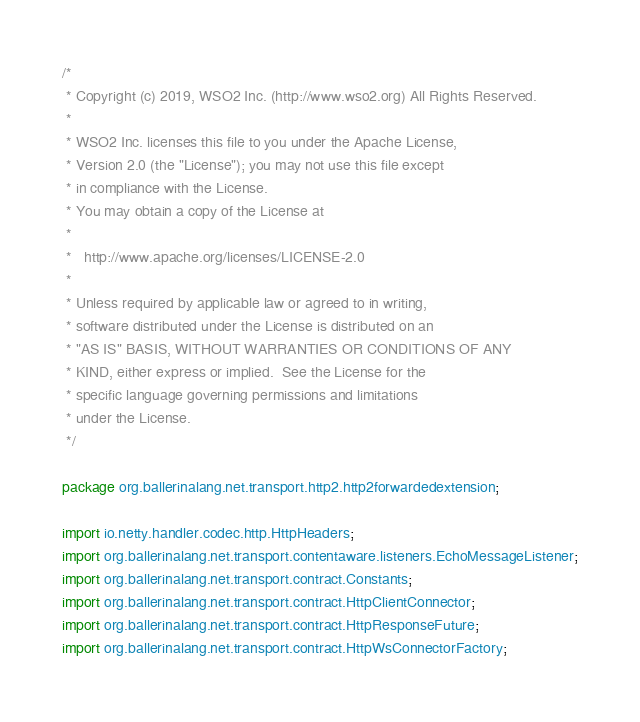<code> <loc_0><loc_0><loc_500><loc_500><_Java_>/*
 * Copyright (c) 2019, WSO2 Inc. (http://www.wso2.org) All Rights Reserved.
 *
 * WSO2 Inc. licenses this file to you under the Apache License,
 * Version 2.0 (the "License"); you may not use this file except
 * in compliance with the License.
 * You may obtain a copy of the License at
 *
 *   http://www.apache.org/licenses/LICENSE-2.0
 *
 * Unless required by applicable law or agreed to in writing,
 * software distributed under the License is distributed on an
 * "AS IS" BASIS, WITHOUT WARRANTIES OR CONDITIONS OF ANY
 * KIND, either express or implied.  See the License for the
 * specific language governing permissions and limitations
 * under the License.
 */

package org.ballerinalang.net.transport.http2.http2forwardedextension;

import io.netty.handler.codec.http.HttpHeaders;
import org.ballerinalang.net.transport.contentaware.listeners.EchoMessageListener;
import org.ballerinalang.net.transport.contract.Constants;
import org.ballerinalang.net.transport.contract.HttpClientConnector;
import org.ballerinalang.net.transport.contract.HttpResponseFuture;
import org.ballerinalang.net.transport.contract.HttpWsConnectorFactory;</code> 